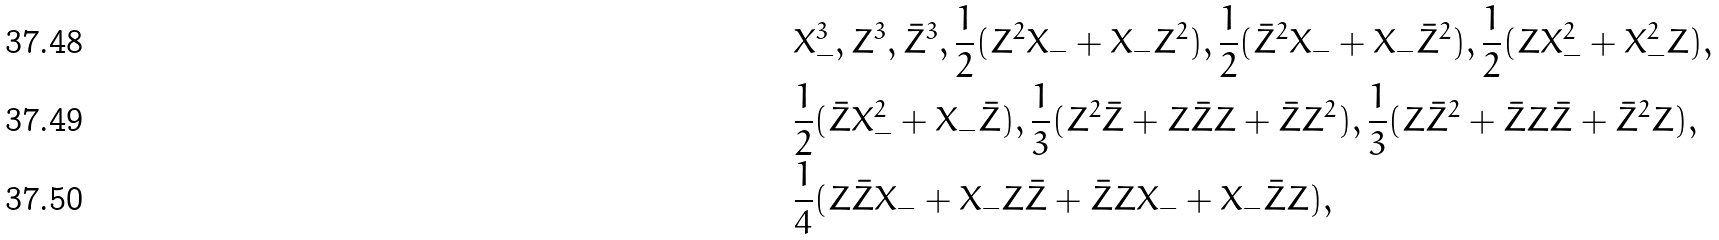Convert formula to latex. <formula><loc_0><loc_0><loc_500><loc_500>& X _ { - } ^ { 3 } , Z ^ { 3 } , \bar { Z } ^ { 3 } , \frac { 1 } { 2 } ( Z ^ { 2 } X _ { - } + X _ { - } Z ^ { 2 } ) , \frac { 1 } { 2 } ( \bar { Z } ^ { 2 } X _ { - } + X _ { - } \bar { Z } ^ { 2 } ) , \frac { 1 } { 2 } ( Z X _ { - } ^ { 2 } + X _ { - } ^ { 2 } Z ) , \\ & \frac { 1 } { 2 } ( \bar { Z } X _ { - } ^ { 2 } + X _ { - } \bar { Z } ) , \frac { 1 } { 3 } ( Z ^ { 2 } \bar { Z } + Z \bar { Z } Z + \bar { Z } Z ^ { 2 } ) , \frac { 1 } { 3 } ( Z \bar { Z } ^ { 2 } + \bar { Z } Z \bar { Z } + \bar { Z } ^ { 2 } Z ) , \\ & \frac { 1 } { 4 } ( Z \bar { Z } X _ { - } + X _ { - } Z \bar { Z } + \bar { Z } Z X _ { - } + X _ { - } \bar { Z } Z ) ,</formula> 